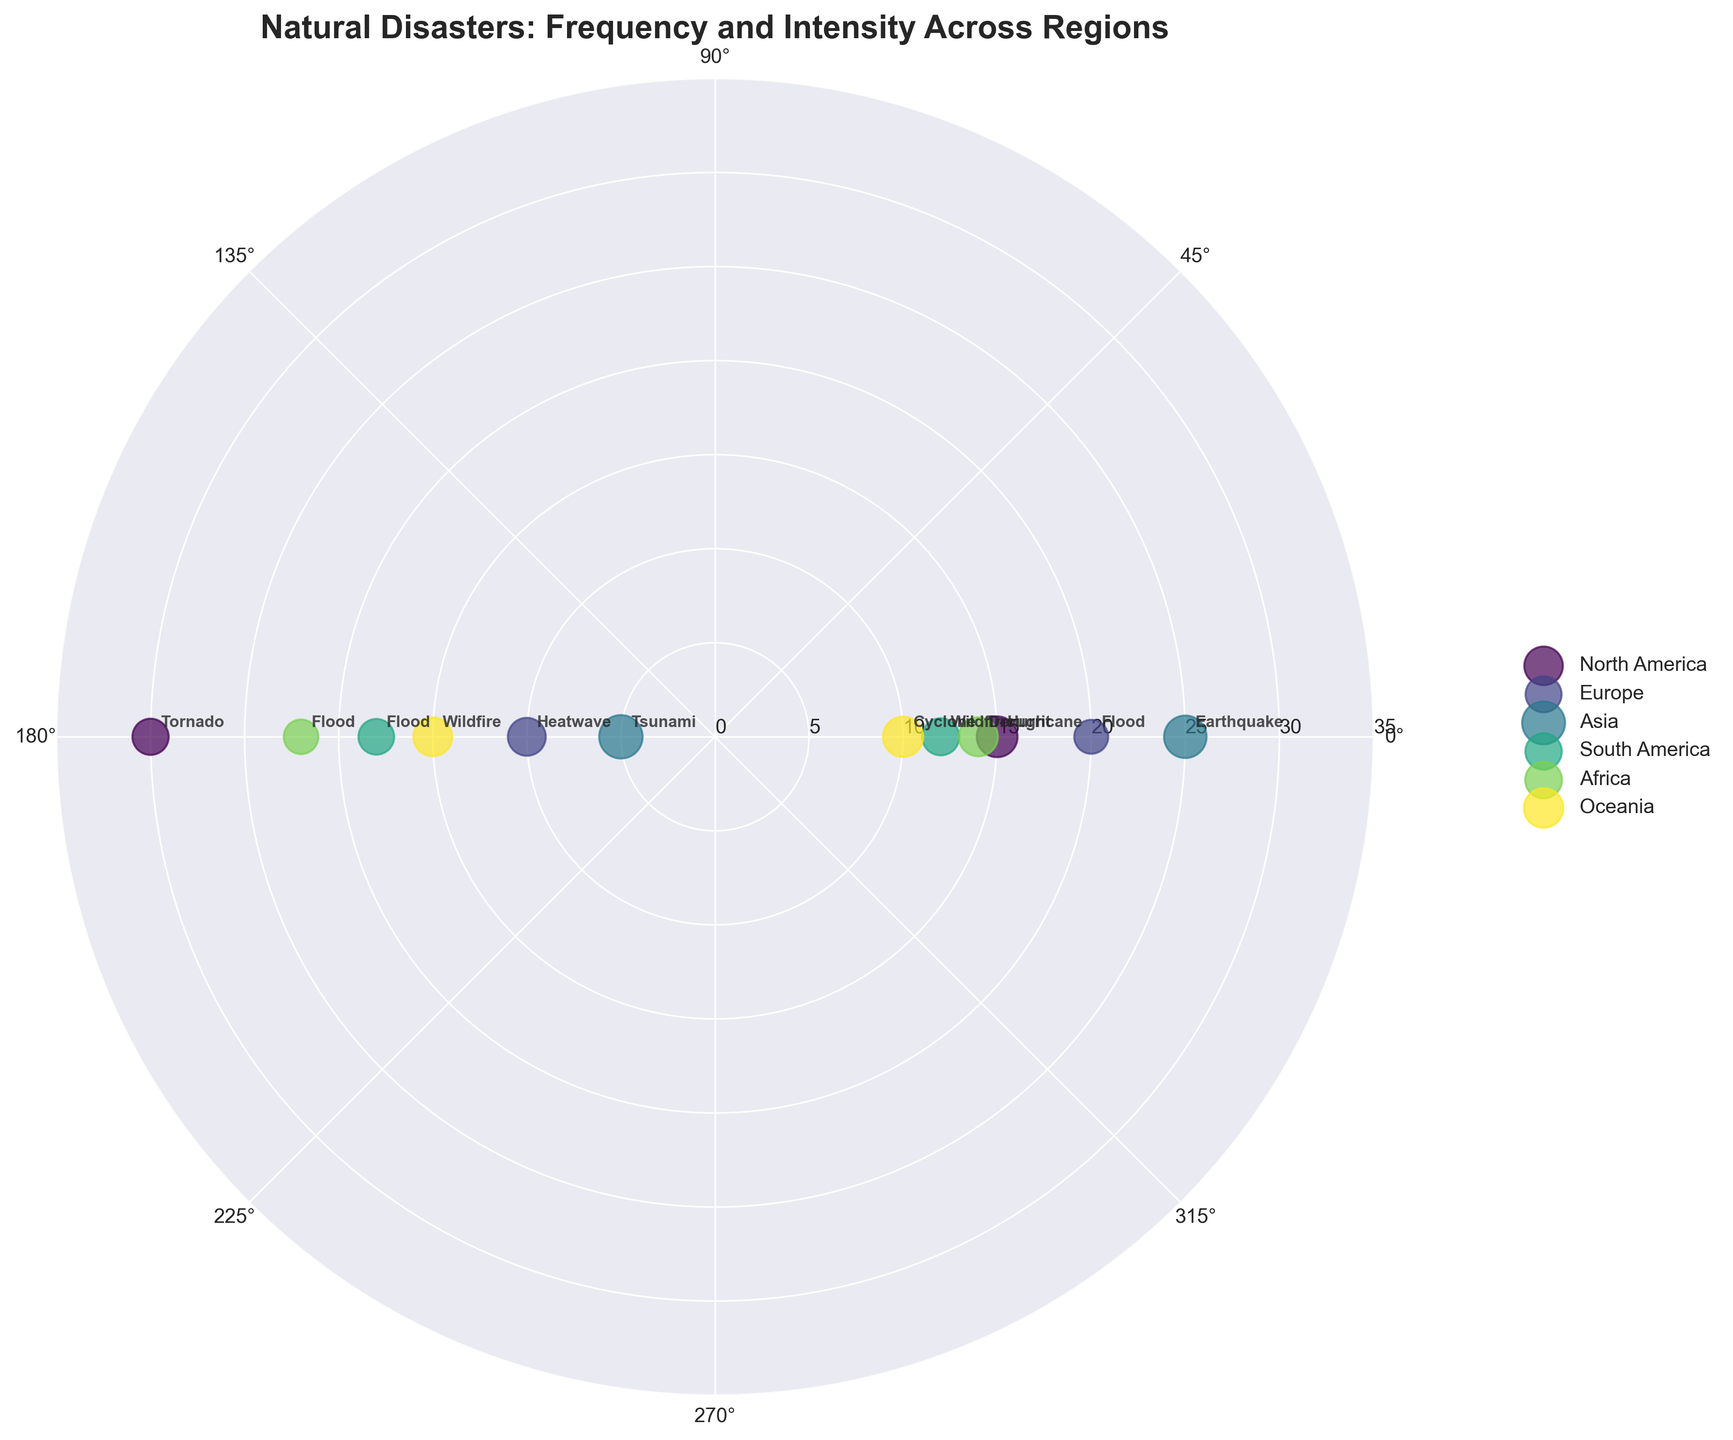what is the most common natural disaster in North America? From the annotated disaster types and their frequencies, Tornado is the most common natural disaster in North America with a frequency of 30.
Answer: Tornado Which region has the disaster with the highest intensity? By checking the annotated intensities, Asia has the highest intensity with the Tsunami disaster at 9.3.
Answer: Asia What is the average frequency of natural disasters in Europe? Europe has 2 disasters: Flood (frequency 20) and Heatwave (frequency 10). The average is (20+10)/2 = 15.
Answer: 15 Compare the intensity of Cyclone in Oceania with Hurricane in North America. Which is higher? Hurricane in North America has an intensity of 8.2, while Cyclone in Oceania has an intensity of 8.0. Hurricane is higher.
Answer: Hurricane What is the total frequency of floods across all regions? Flood appears in Europe (20), South America (18), and Africa (22). The total frequency is 20+18+22 = 60.
Answer: 60 How many regions experienced wildfires? Wildfires are annotated in South America and Oceania. Thus, 2 regions have experienced wildfires.
Answer: 2 Which disaster has both high frequency and high intensity in Asia? Earthquake in Asia has both a high frequency (25) and high intensity (8.9).
Answer: Earthquake In which region is the intensity of natural disasters more uniformly distributed? From observing the varied size of scatter points across regions, Europe shows a more uniform distribution in intensity with flood (5.7) and heatwave (7.1).
Answer: Europe What type of chart is used to visualize the data? The chart is a Polar Scatter Chart, as indicated by the radial layout and scatter points.
Answer: Polar Scatter Chart 